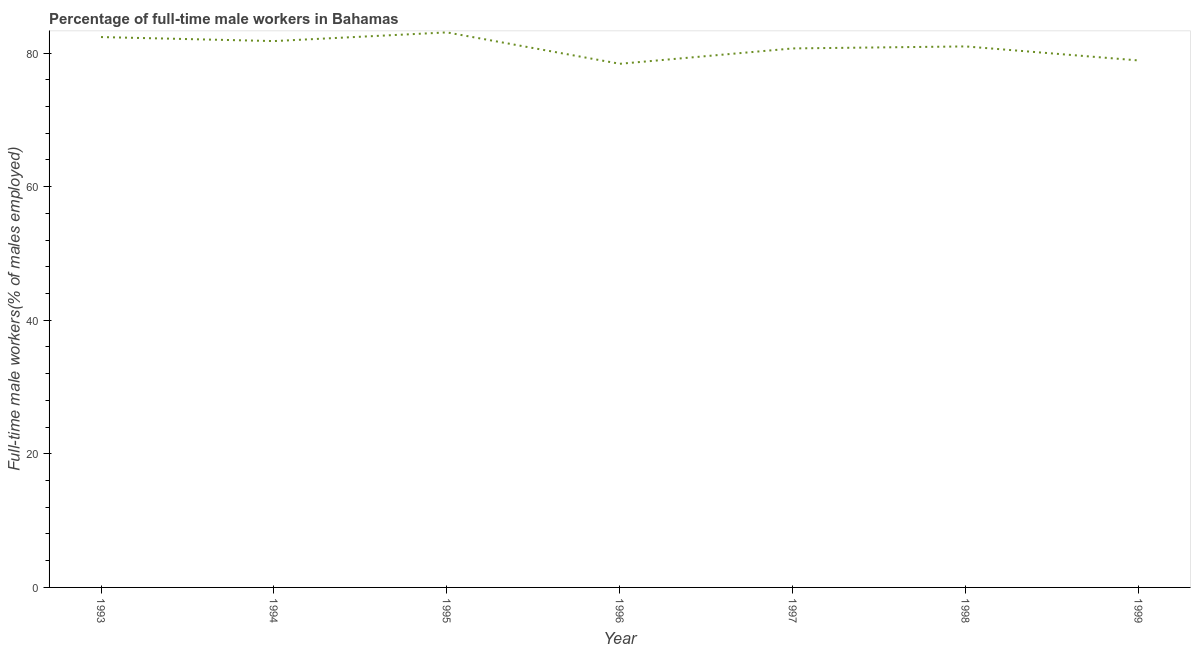What is the percentage of full-time male workers in 1994?
Ensure brevity in your answer.  81.8. Across all years, what is the maximum percentage of full-time male workers?
Make the answer very short. 83.1. Across all years, what is the minimum percentage of full-time male workers?
Make the answer very short. 78.4. In which year was the percentage of full-time male workers minimum?
Your response must be concise. 1996. What is the sum of the percentage of full-time male workers?
Ensure brevity in your answer.  566.3. What is the difference between the percentage of full-time male workers in 1997 and 1998?
Offer a very short reply. -0.3. What is the average percentage of full-time male workers per year?
Provide a succinct answer. 80.9. Do a majority of the years between 1995 and 1997 (inclusive) have percentage of full-time male workers greater than 72 %?
Your answer should be very brief. Yes. What is the ratio of the percentage of full-time male workers in 1996 to that in 1997?
Your answer should be compact. 0.97. Is the percentage of full-time male workers in 1996 less than that in 1999?
Your answer should be compact. Yes. Is the difference between the percentage of full-time male workers in 1997 and 1998 greater than the difference between any two years?
Your response must be concise. No. What is the difference between the highest and the second highest percentage of full-time male workers?
Offer a terse response. 0.7. What is the difference between the highest and the lowest percentage of full-time male workers?
Keep it short and to the point. 4.7. How many lines are there?
Your answer should be very brief. 1. How many years are there in the graph?
Offer a terse response. 7. Are the values on the major ticks of Y-axis written in scientific E-notation?
Give a very brief answer. No. Does the graph contain grids?
Your response must be concise. No. What is the title of the graph?
Keep it short and to the point. Percentage of full-time male workers in Bahamas. What is the label or title of the X-axis?
Offer a terse response. Year. What is the label or title of the Y-axis?
Ensure brevity in your answer.  Full-time male workers(% of males employed). What is the Full-time male workers(% of males employed) of 1993?
Your answer should be compact. 82.4. What is the Full-time male workers(% of males employed) in 1994?
Give a very brief answer. 81.8. What is the Full-time male workers(% of males employed) in 1995?
Your response must be concise. 83.1. What is the Full-time male workers(% of males employed) of 1996?
Offer a terse response. 78.4. What is the Full-time male workers(% of males employed) of 1997?
Your answer should be very brief. 80.7. What is the Full-time male workers(% of males employed) in 1999?
Offer a terse response. 78.9. What is the difference between the Full-time male workers(% of males employed) in 1993 and 1994?
Offer a terse response. 0.6. What is the difference between the Full-time male workers(% of males employed) in 1993 and 1995?
Ensure brevity in your answer.  -0.7. What is the difference between the Full-time male workers(% of males employed) in 1993 and 1997?
Give a very brief answer. 1.7. What is the difference between the Full-time male workers(% of males employed) in 1993 and 1998?
Your answer should be compact. 1.4. What is the difference between the Full-time male workers(% of males employed) in 1993 and 1999?
Provide a succinct answer. 3.5. What is the difference between the Full-time male workers(% of males employed) in 1994 and 1997?
Keep it short and to the point. 1.1. What is the difference between the Full-time male workers(% of males employed) in 1994 and 1998?
Keep it short and to the point. 0.8. What is the difference between the Full-time male workers(% of males employed) in 1995 and 1997?
Make the answer very short. 2.4. What is the difference between the Full-time male workers(% of males employed) in 1995 and 1999?
Provide a succinct answer. 4.2. What is the difference between the Full-time male workers(% of males employed) in 1996 and 1998?
Give a very brief answer. -2.6. What is the difference between the Full-time male workers(% of males employed) in 1996 and 1999?
Your answer should be very brief. -0.5. What is the difference between the Full-time male workers(% of males employed) in 1997 and 1998?
Offer a terse response. -0.3. What is the ratio of the Full-time male workers(% of males employed) in 1993 to that in 1994?
Your answer should be very brief. 1.01. What is the ratio of the Full-time male workers(% of males employed) in 1993 to that in 1996?
Give a very brief answer. 1.05. What is the ratio of the Full-time male workers(% of males employed) in 1993 to that in 1998?
Ensure brevity in your answer.  1.02. What is the ratio of the Full-time male workers(% of males employed) in 1993 to that in 1999?
Provide a short and direct response. 1.04. What is the ratio of the Full-time male workers(% of males employed) in 1994 to that in 1996?
Provide a short and direct response. 1.04. What is the ratio of the Full-time male workers(% of males employed) in 1994 to that in 1997?
Your response must be concise. 1.01. What is the ratio of the Full-time male workers(% of males employed) in 1995 to that in 1996?
Offer a terse response. 1.06. What is the ratio of the Full-time male workers(% of males employed) in 1995 to that in 1998?
Give a very brief answer. 1.03. What is the ratio of the Full-time male workers(% of males employed) in 1995 to that in 1999?
Your answer should be very brief. 1.05. What is the ratio of the Full-time male workers(% of males employed) in 1996 to that in 1998?
Your answer should be compact. 0.97. What is the ratio of the Full-time male workers(% of males employed) in 1997 to that in 1998?
Your response must be concise. 1. What is the ratio of the Full-time male workers(% of males employed) in 1997 to that in 1999?
Your response must be concise. 1.02. What is the ratio of the Full-time male workers(% of males employed) in 1998 to that in 1999?
Offer a very short reply. 1.03. 